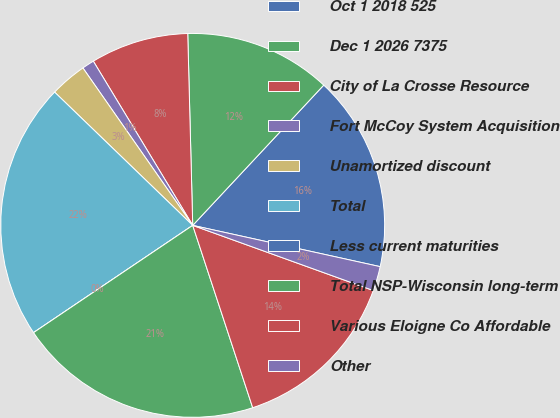<chart> <loc_0><loc_0><loc_500><loc_500><pie_chart><fcel>Oct 1 2018 525<fcel>Dec 1 2026 7375<fcel>City of La Crosse Resource<fcel>Fort McCoy System Acquisition<fcel>Unamortized discount<fcel>Total<fcel>Less current maturities<fcel>Total NSP-Wisconsin long-term<fcel>Various Eloigne Co Affordable<fcel>Other<nl><fcel>16.49%<fcel>12.37%<fcel>8.25%<fcel>1.03%<fcel>3.09%<fcel>21.65%<fcel>0.0%<fcel>20.62%<fcel>14.43%<fcel>2.06%<nl></chart> 